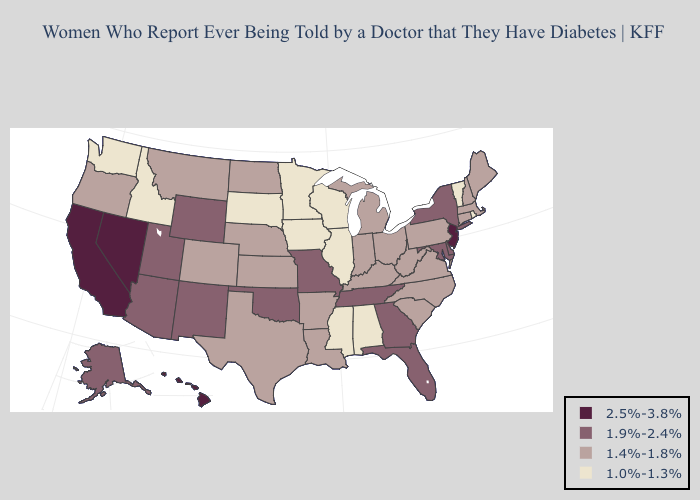Name the states that have a value in the range 1.4%-1.8%?
Give a very brief answer. Arkansas, Colorado, Connecticut, Indiana, Kansas, Kentucky, Louisiana, Maine, Massachusetts, Michigan, Montana, Nebraska, New Hampshire, North Carolina, North Dakota, Ohio, Oregon, Pennsylvania, South Carolina, Texas, Virginia, West Virginia. What is the highest value in the USA?
Answer briefly. 2.5%-3.8%. Name the states that have a value in the range 1.9%-2.4%?
Give a very brief answer. Alaska, Arizona, Delaware, Florida, Georgia, Maryland, Missouri, New Mexico, New York, Oklahoma, Tennessee, Utah, Wyoming. What is the highest value in the Northeast ?
Give a very brief answer. 2.5%-3.8%. Does South Carolina have the same value as Wyoming?
Concise answer only. No. What is the value of Idaho?
Write a very short answer. 1.0%-1.3%. Which states have the lowest value in the USA?
Short answer required. Alabama, Idaho, Illinois, Iowa, Minnesota, Mississippi, Rhode Island, South Dakota, Vermont, Washington, Wisconsin. Does Indiana have the lowest value in the MidWest?
Concise answer only. No. Does Nevada have the highest value in the USA?
Answer briefly. Yes. What is the lowest value in the USA?
Write a very short answer. 1.0%-1.3%. What is the lowest value in the South?
Be succinct. 1.0%-1.3%. Name the states that have a value in the range 2.5%-3.8%?
Short answer required. California, Hawaii, Nevada, New Jersey. Which states hav the highest value in the West?
Answer briefly. California, Hawaii, Nevada. What is the highest value in the Northeast ?
Short answer required. 2.5%-3.8%. 